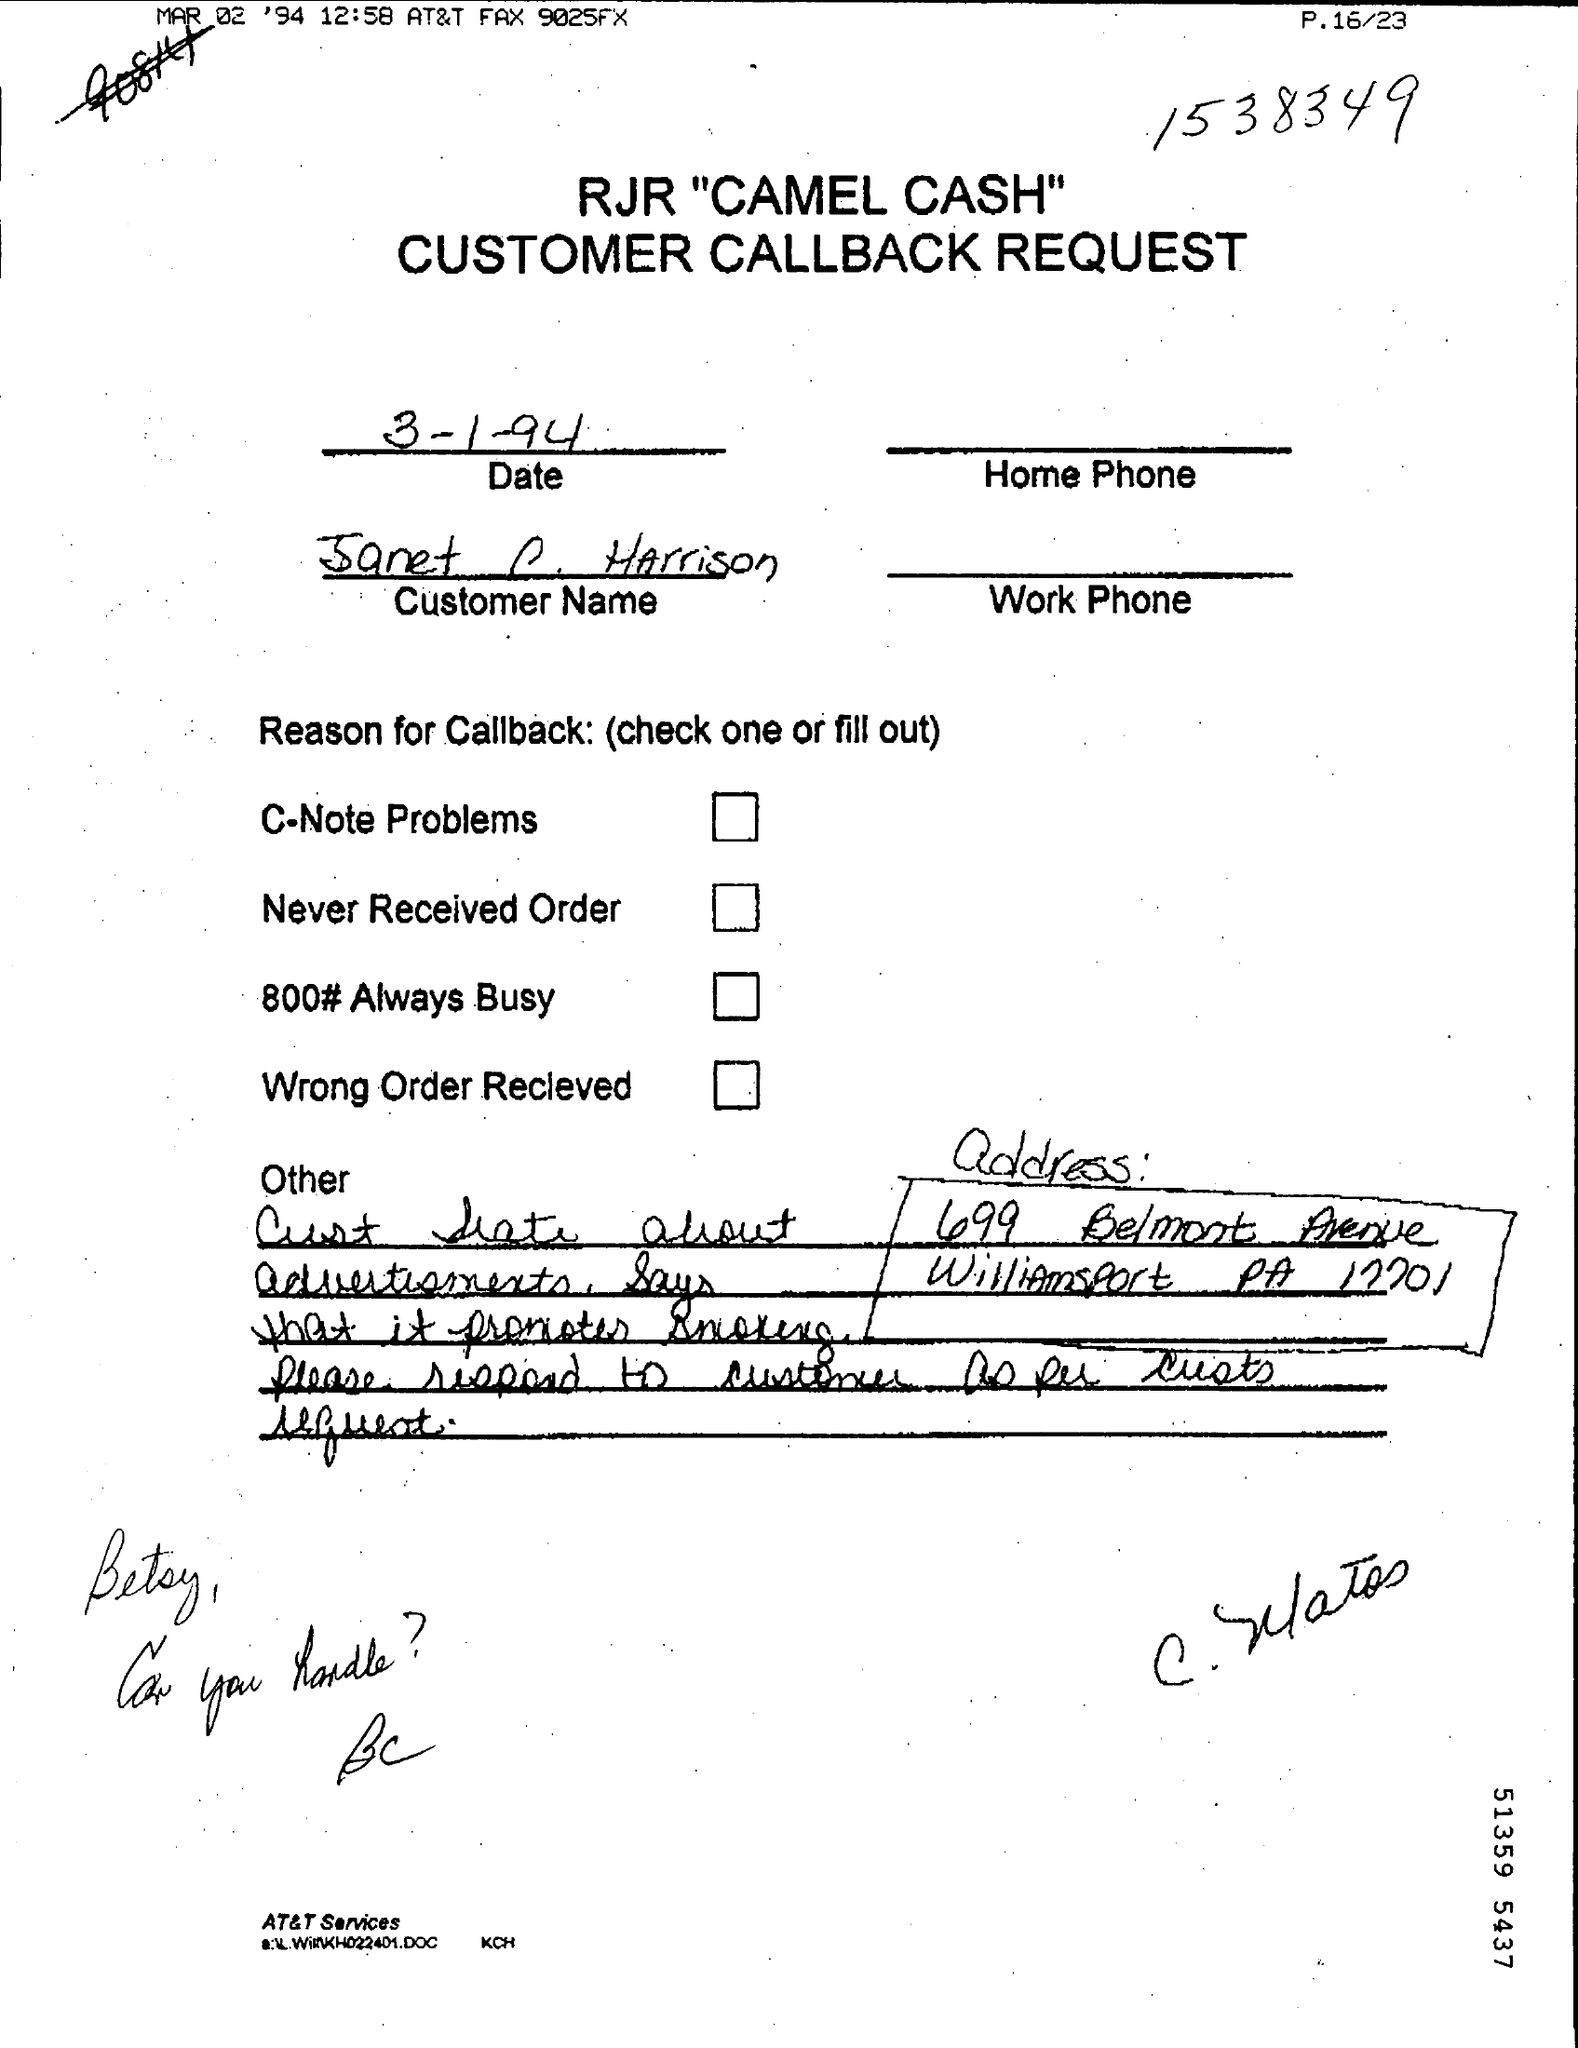Highlight a few significant elements in this photo. The date mentioned on the page is March 1, 1994. The request mentioned in the given page is titled "Customer Callback Request. 